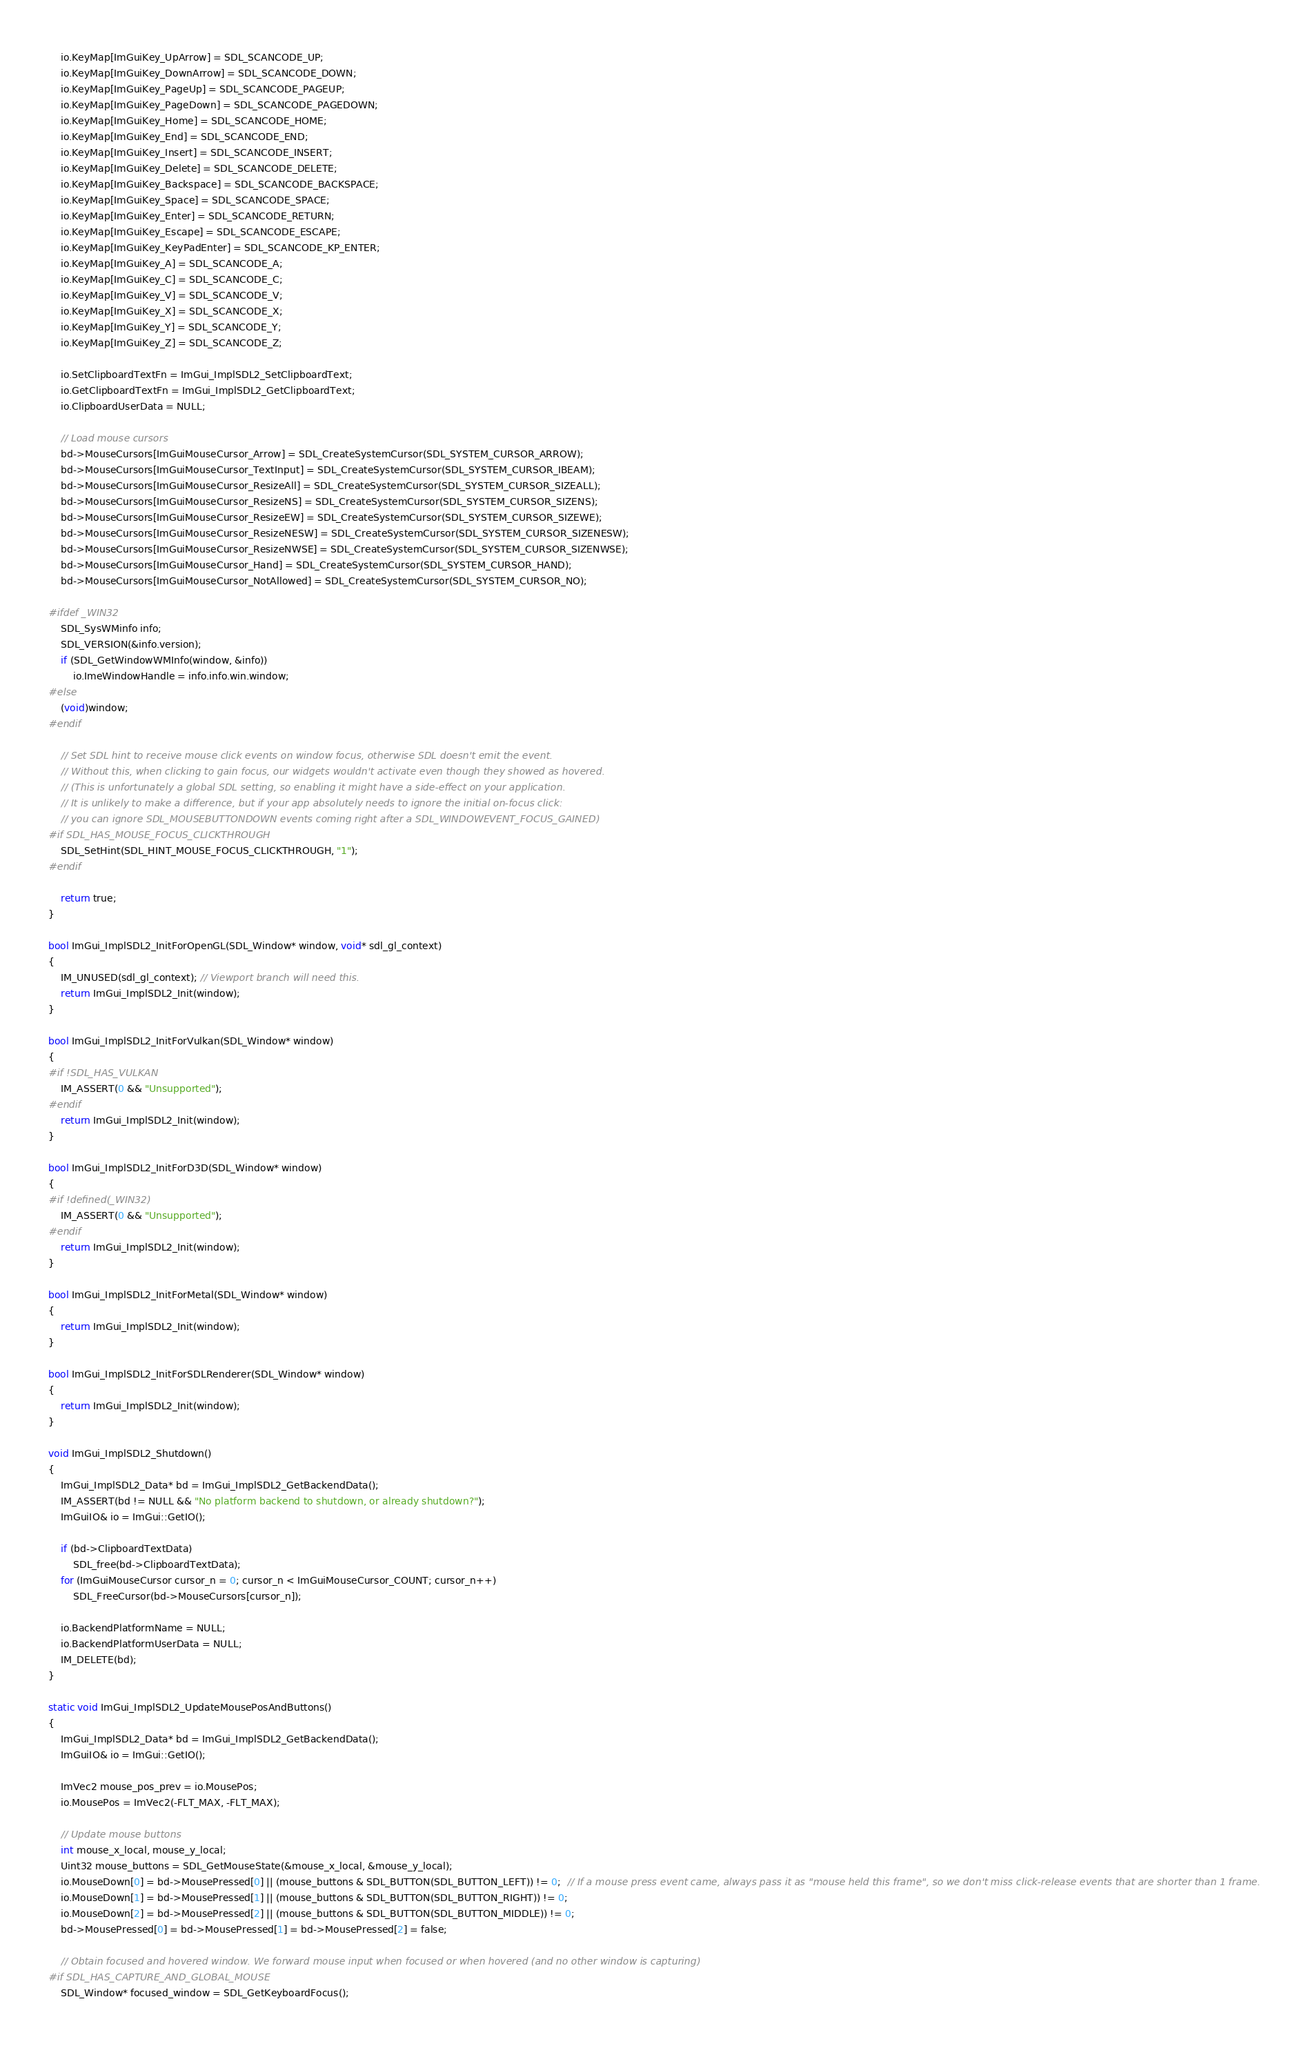<code> <loc_0><loc_0><loc_500><loc_500><_C++_>    io.KeyMap[ImGuiKey_UpArrow] = SDL_SCANCODE_UP;
    io.KeyMap[ImGuiKey_DownArrow] = SDL_SCANCODE_DOWN;
    io.KeyMap[ImGuiKey_PageUp] = SDL_SCANCODE_PAGEUP;
    io.KeyMap[ImGuiKey_PageDown] = SDL_SCANCODE_PAGEDOWN;
    io.KeyMap[ImGuiKey_Home] = SDL_SCANCODE_HOME;
    io.KeyMap[ImGuiKey_End] = SDL_SCANCODE_END;
    io.KeyMap[ImGuiKey_Insert] = SDL_SCANCODE_INSERT;
    io.KeyMap[ImGuiKey_Delete] = SDL_SCANCODE_DELETE;
    io.KeyMap[ImGuiKey_Backspace] = SDL_SCANCODE_BACKSPACE;
    io.KeyMap[ImGuiKey_Space] = SDL_SCANCODE_SPACE;
    io.KeyMap[ImGuiKey_Enter] = SDL_SCANCODE_RETURN;
    io.KeyMap[ImGuiKey_Escape] = SDL_SCANCODE_ESCAPE;
    io.KeyMap[ImGuiKey_KeyPadEnter] = SDL_SCANCODE_KP_ENTER;
    io.KeyMap[ImGuiKey_A] = SDL_SCANCODE_A;
    io.KeyMap[ImGuiKey_C] = SDL_SCANCODE_C;
    io.KeyMap[ImGuiKey_V] = SDL_SCANCODE_V;
    io.KeyMap[ImGuiKey_X] = SDL_SCANCODE_X;
    io.KeyMap[ImGuiKey_Y] = SDL_SCANCODE_Y;
    io.KeyMap[ImGuiKey_Z] = SDL_SCANCODE_Z;

    io.SetClipboardTextFn = ImGui_ImplSDL2_SetClipboardText;
    io.GetClipboardTextFn = ImGui_ImplSDL2_GetClipboardText;
    io.ClipboardUserData = NULL;

    // Load mouse cursors
    bd->MouseCursors[ImGuiMouseCursor_Arrow] = SDL_CreateSystemCursor(SDL_SYSTEM_CURSOR_ARROW);
    bd->MouseCursors[ImGuiMouseCursor_TextInput] = SDL_CreateSystemCursor(SDL_SYSTEM_CURSOR_IBEAM);
    bd->MouseCursors[ImGuiMouseCursor_ResizeAll] = SDL_CreateSystemCursor(SDL_SYSTEM_CURSOR_SIZEALL);
    bd->MouseCursors[ImGuiMouseCursor_ResizeNS] = SDL_CreateSystemCursor(SDL_SYSTEM_CURSOR_SIZENS);
    bd->MouseCursors[ImGuiMouseCursor_ResizeEW] = SDL_CreateSystemCursor(SDL_SYSTEM_CURSOR_SIZEWE);
    bd->MouseCursors[ImGuiMouseCursor_ResizeNESW] = SDL_CreateSystemCursor(SDL_SYSTEM_CURSOR_SIZENESW);
    bd->MouseCursors[ImGuiMouseCursor_ResizeNWSE] = SDL_CreateSystemCursor(SDL_SYSTEM_CURSOR_SIZENWSE);
    bd->MouseCursors[ImGuiMouseCursor_Hand] = SDL_CreateSystemCursor(SDL_SYSTEM_CURSOR_HAND);
    bd->MouseCursors[ImGuiMouseCursor_NotAllowed] = SDL_CreateSystemCursor(SDL_SYSTEM_CURSOR_NO);

#ifdef _WIN32
    SDL_SysWMinfo info;
    SDL_VERSION(&info.version);
    if (SDL_GetWindowWMInfo(window, &info))
        io.ImeWindowHandle = info.info.win.window;
#else
    (void)window;
#endif

    // Set SDL hint to receive mouse click events on window focus, otherwise SDL doesn't emit the event.
    // Without this, when clicking to gain focus, our widgets wouldn't activate even though they showed as hovered.
    // (This is unfortunately a global SDL setting, so enabling it might have a side-effect on your application.
    // It is unlikely to make a difference, but if your app absolutely needs to ignore the initial on-focus click:
    // you can ignore SDL_MOUSEBUTTONDOWN events coming right after a SDL_WINDOWEVENT_FOCUS_GAINED)
#if SDL_HAS_MOUSE_FOCUS_CLICKTHROUGH
    SDL_SetHint(SDL_HINT_MOUSE_FOCUS_CLICKTHROUGH, "1");
#endif

    return true;
}

bool ImGui_ImplSDL2_InitForOpenGL(SDL_Window* window, void* sdl_gl_context)
{
    IM_UNUSED(sdl_gl_context); // Viewport branch will need this.
    return ImGui_ImplSDL2_Init(window);
}

bool ImGui_ImplSDL2_InitForVulkan(SDL_Window* window)
{
#if !SDL_HAS_VULKAN
    IM_ASSERT(0 && "Unsupported");
#endif
    return ImGui_ImplSDL2_Init(window);
}

bool ImGui_ImplSDL2_InitForD3D(SDL_Window* window)
{
#if !defined(_WIN32)
    IM_ASSERT(0 && "Unsupported");
#endif
    return ImGui_ImplSDL2_Init(window);
}

bool ImGui_ImplSDL2_InitForMetal(SDL_Window* window)
{
    return ImGui_ImplSDL2_Init(window);
}

bool ImGui_ImplSDL2_InitForSDLRenderer(SDL_Window* window)
{
    return ImGui_ImplSDL2_Init(window);
}

void ImGui_ImplSDL2_Shutdown()
{
    ImGui_ImplSDL2_Data* bd = ImGui_ImplSDL2_GetBackendData();
    IM_ASSERT(bd != NULL && "No platform backend to shutdown, or already shutdown?");
    ImGuiIO& io = ImGui::GetIO();

    if (bd->ClipboardTextData)
        SDL_free(bd->ClipboardTextData);
    for (ImGuiMouseCursor cursor_n = 0; cursor_n < ImGuiMouseCursor_COUNT; cursor_n++)
        SDL_FreeCursor(bd->MouseCursors[cursor_n]);

    io.BackendPlatformName = NULL;
    io.BackendPlatformUserData = NULL;
    IM_DELETE(bd);
}

static void ImGui_ImplSDL2_UpdateMousePosAndButtons()
{
    ImGui_ImplSDL2_Data* bd = ImGui_ImplSDL2_GetBackendData();
    ImGuiIO& io = ImGui::GetIO();

    ImVec2 mouse_pos_prev = io.MousePos;
    io.MousePos = ImVec2(-FLT_MAX, -FLT_MAX);

    // Update mouse buttons
    int mouse_x_local, mouse_y_local;
    Uint32 mouse_buttons = SDL_GetMouseState(&mouse_x_local, &mouse_y_local);
    io.MouseDown[0] = bd->MousePressed[0] || (mouse_buttons & SDL_BUTTON(SDL_BUTTON_LEFT)) != 0;  // If a mouse press event came, always pass it as "mouse held this frame", so we don't miss click-release events that are shorter than 1 frame.
    io.MouseDown[1] = bd->MousePressed[1] || (mouse_buttons & SDL_BUTTON(SDL_BUTTON_RIGHT)) != 0;
    io.MouseDown[2] = bd->MousePressed[2] || (mouse_buttons & SDL_BUTTON(SDL_BUTTON_MIDDLE)) != 0;
    bd->MousePressed[0] = bd->MousePressed[1] = bd->MousePressed[2] = false;

    // Obtain focused and hovered window. We forward mouse input when focused or when hovered (and no other window is capturing)
#if SDL_HAS_CAPTURE_AND_GLOBAL_MOUSE
    SDL_Window* focused_window = SDL_GetKeyboardFocus();</code> 